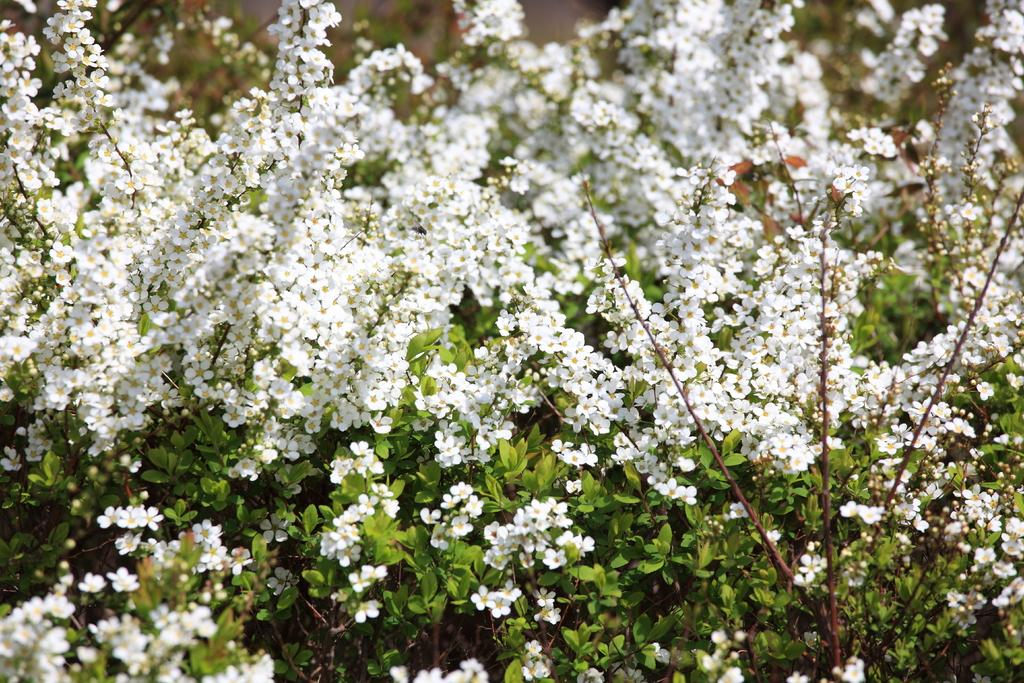What type of plants can be seen in the image? There are flower plants in the image. Can you describe the appearance of the flower plants? Unfortunately, the image does not provide enough detail to describe the appearance of the flower plants. Are there any other objects or elements visible in the image? The provided facts only mention the presence of flower plants, so there is no information about any other objects or elements in the image. What type of ring is the flower plant wearing in the image? There is no ring present in the image, as the subject is a flower plant, which is a plant and not capable of wearing a ring. 